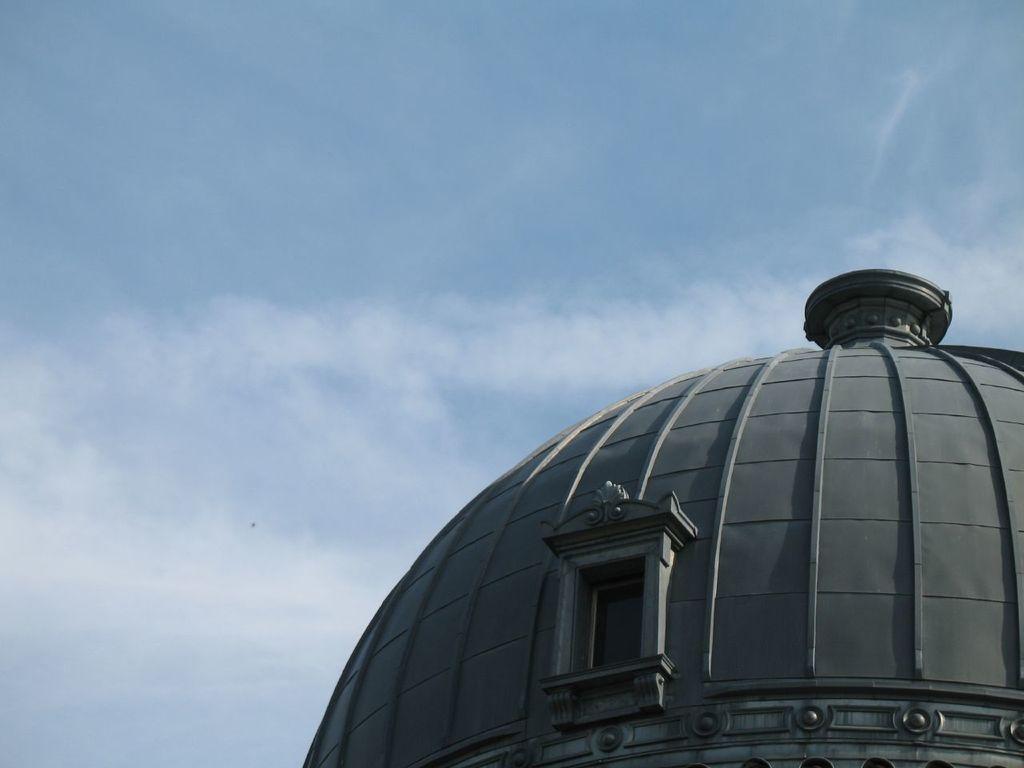Could you give a brief overview of what you see in this image? In this image I can see the sky and top of the tower and window on the tower. 